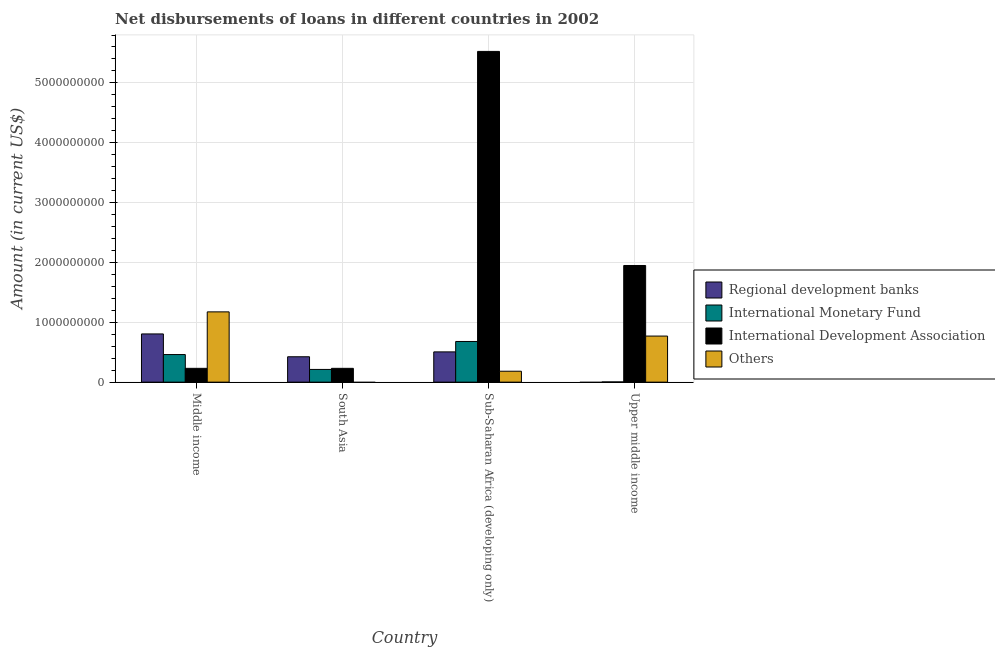How many different coloured bars are there?
Your answer should be very brief. 4. Are the number of bars per tick equal to the number of legend labels?
Give a very brief answer. No. What is the label of the 1st group of bars from the left?
Offer a very short reply. Middle income. What is the amount of loan disimbursed by international monetary fund in South Asia?
Ensure brevity in your answer.  2.13e+08. Across all countries, what is the maximum amount of loan disimbursed by regional development banks?
Provide a succinct answer. 8.05e+08. In which country was the amount of loan disimbursed by international development association maximum?
Offer a terse response. Sub-Saharan Africa (developing only). What is the total amount of loan disimbursed by international monetary fund in the graph?
Keep it short and to the point. 1.36e+09. What is the difference between the amount of loan disimbursed by international development association in Middle income and that in Sub-Saharan Africa (developing only)?
Offer a terse response. -5.30e+09. What is the difference between the amount of loan disimbursed by regional development banks in Middle income and the amount of loan disimbursed by international development association in South Asia?
Your answer should be very brief. 5.75e+08. What is the average amount of loan disimbursed by regional development banks per country?
Ensure brevity in your answer.  4.34e+08. What is the difference between the amount of loan disimbursed by regional development banks and amount of loan disimbursed by international monetary fund in Sub-Saharan Africa (developing only)?
Your answer should be very brief. -1.74e+08. In how many countries, is the amount of loan disimbursed by other organisations greater than 800000000 US$?
Provide a succinct answer. 1. What is the ratio of the amount of loan disimbursed by international development association in Sub-Saharan Africa (developing only) to that in Upper middle income?
Keep it short and to the point. 2.84. Is the difference between the amount of loan disimbursed by international development association in Middle income and South Asia greater than the difference between the amount of loan disimbursed by international monetary fund in Middle income and South Asia?
Offer a very short reply. No. What is the difference between the highest and the second highest amount of loan disimbursed by regional development banks?
Your answer should be compact. 3.00e+08. What is the difference between the highest and the lowest amount of loan disimbursed by international development association?
Offer a very short reply. 5.30e+09. In how many countries, is the amount of loan disimbursed by regional development banks greater than the average amount of loan disimbursed by regional development banks taken over all countries?
Keep it short and to the point. 2. Is the sum of the amount of loan disimbursed by international development association in South Asia and Upper middle income greater than the maximum amount of loan disimbursed by international monetary fund across all countries?
Provide a short and direct response. Yes. Is it the case that in every country, the sum of the amount of loan disimbursed by regional development banks and amount of loan disimbursed by international monetary fund is greater than the amount of loan disimbursed by international development association?
Provide a succinct answer. No. How many bars are there?
Offer a very short reply. 14. Are the values on the major ticks of Y-axis written in scientific E-notation?
Provide a short and direct response. No. Does the graph contain any zero values?
Make the answer very short. Yes. Does the graph contain grids?
Give a very brief answer. Yes. How are the legend labels stacked?
Offer a terse response. Vertical. What is the title of the graph?
Your answer should be compact. Net disbursements of loans in different countries in 2002. What is the label or title of the Y-axis?
Your answer should be very brief. Amount (in current US$). What is the Amount (in current US$) of Regional development banks in Middle income?
Ensure brevity in your answer.  8.05e+08. What is the Amount (in current US$) of International Monetary Fund in Middle income?
Offer a very short reply. 4.61e+08. What is the Amount (in current US$) in International Development Association in Middle income?
Your answer should be very brief. 2.31e+08. What is the Amount (in current US$) of Others in Middle income?
Your response must be concise. 1.17e+09. What is the Amount (in current US$) in Regional development banks in South Asia?
Provide a short and direct response. 4.24e+08. What is the Amount (in current US$) in International Monetary Fund in South Asia?
Make the answer very short. 2.13e+08. What is the Amount (in current US$) in International Development Association in South Asia?
Give a very brief answer. 2.31e+08. What is the Amount (in current US$) of Regional development banks in Sub-Saharan Africa (developing only)?
Your answer should be compact. 5.06e+08. What is the Amount (in current US$) of International Monetary Fund in Sub-Saharan Africa (developing only)?
Your answer should be compact. 6.80e+08. What is the Amount (in current US$) in International Development Association in Sub-Saharan Africa (developing only)?
Your answer should be compact. 5.53e+09. What is the Amount (in current US$) in Others in Sub-Saharan Africa (developing only)?
Make the answer very short. 1.82e+08. What is the Amount (in current US$) of International Monetary Fund in Upper middle income?
Make the answer very short. 3.73e+06. What is the Amount (in current US$) of International Development Association in Upper middle income?
Make the answer very short. 1.95e+09. What is the Amount (in current US$) in Others in Upper middle income?
Keep it short and to the point. 7.70e+08. Across all countries, what is the maximum Amount (in current US$) in Regional development banks?
Offer a very short reply. 8.05e+08. Across all countries, what is the maximum Amount (in current US$) of International Monetary Fund?
Keep it short and to the point. 6.80e+08. Across all countries, what is the maximum Amount (in current US$) of International Development Association?
Offer a terse response. 5.53e+09. Across all countries, what is the maximum Amount (in current US$) of Others?
Your answer should be very brief. 1.17e+09. Across all countries, what is the minimum Amount (in current US$) of Regional development banks?
Your answer should be very brief. 0. Across all countries, what is the minimum Amount (in current US$) in International Monetary Fund?
Provide a succinct answer. 3.73e+06. Across all countries, what is the minimum Amount (in current US$) in International Development Association?
Provide a succinct answer. 2.31e+08. Across all countries, what is the minimum Amount (in current US$) in Others?
Your answer should be compact. 0. What is the total Amount (in current US$) of Regional development banks in the graph?
Your answer should be very brief. 1.74e+09. What is the total Amount (in current US$) in International Monetary Fund in the graph?
Keep it short and to the point. 1.36e+09. What is the total Amount (in current US$) of International Development Association in the graph?
Offer a terse response. 7.94e+09. What is the total Amount (in current US$) in Others in the graph?
Your answer should be very brief. 2.13e+09. What is the difference between the Amount (in current US$) in Regional development banks in Middle income and that in South Asia?
Your answer should be very brief. 3.81e+08. What is the difference between the Amount (in current US$) of International Monetary Fund in Middle income and that in South Asia?
Your answer should be compact. 2.48e+08. What is the difference between the Amount (in current US$) in International Development Association in Middle income and that in South Asia?
Your answer should be compact. -3.60e+04. What is the difference between the Amount (in current US$) in Regional development banks in Middle income and that in Sub-Saharan Africa (developing only)?
Your answer should be compact. 3.00e+08. What is the difference between the Amount (in current US$) of International Monetary Fund in Middle income and that in Sub-Saharan Africa (developing only)?
Give a very brief answer. -2.19e+08. What is the difference between the Amount (in current US$) of International Development Association in Middle income and that in Sub-Saharan Africa (developing only)?
Provide a short and direct response. -5.30e+09. What is the difference between the Amount (in current US$) in Others in Middle income and that in Sub-Saharan Africa (developing only)?
Offer a terse response. 9.92e+08. What is the difference between the Amount (in current US$) of International Monetary Fund in Middle income and that in Upper middle income?
Offer a very short reply. 4.57e+08. What is the difference between the Amount (in current US$) of International Development Association in Middle income and that in Upper middle income?
Ensure brevity in your answer.  -1.72e+09. What is the difference between the Amount (in current US$) of Others in Middle income and that in Upper middle income?
Keep it short and to the point. 4.04e+08. What is the difference between the Amount (in current US$) in Regional development banks in South Asia and that in Sub-Saharan Africa (developing only)?
Give a very brief answer. -8.13e+07. What is the difference between the Amount (in current US$) of International Monetary Fund in South Asia and that in Sub-Saharan Africa (developing only)?
Provide a short and direct response. -4.67e+08. What is the difference between the Amount (in current US$) of International Development Association in South Asia and that in Sub-Saharan Africa (developing only)?
Offer a very short reply. -5.30e+09. What is the difference between the Amount (in current US$) in International Monetary Fund in South Asia and that in Upper middle income?
Give a very brief answer. 2.09e+08. What is the difference between the Amount (in current US$) in International Development Association in South Asia and that in Upper middle income?
Make the answer very short. -1.72e+09. What is the difference between the Amount (in current US$) in International Monetary Fund in Sub-Saharan Africa (developing only) and that in Upper middle income?
Offer a very short reply. 6.76e+08. What is the difference between the Amount (in current US$) in International Development Association in Sub-Saharan Africa (developing only) and that in Upper middle income?
Give a very brief answer. 3.58e+09. What is the difference between the Amount (in current US$) of Others in Sub-Saharan Africa (developing only) and that in Upper middle income?
Ensure brevity in your answer.  -5.87e+08. What is the difference between the Amount (in current US$) of Regional development banks in Middle income and the Amount (in current US$) of International Monetary Fund in South Asia?
Offer a terse response. 5.93e+08. What is the difference between the Amount (in current US$) of Regional development banks in Middle income and the Amount (in current US$) of International Development Association in South Asia?
Your response must be concise. 5.75e+08. What is the difference between the Amount (in current US$) in International Monetary Fund in Middle income and the Amount (in current US$) in International Development Association in South Asia?
Your response must be concise. 2.30e+08. What is the difference between the Amount (in current US$) of Regional development banks in Middle income and the Amount (in current US$) of International Monetary Fund in Sub-Saharan Africa (developing only)?
Offer a very short reply. 1.26e+08. What is the difference between the Amount (in current US$) in Regional development banks in Middle income and the Amount (in current US$) in International Development Association in Sub-Saharan Africa (developing only)?
Provide a succinct answer. -4.72e+09. What is the difference between the Amount (in current US$) in Regional development banks in Middle income and the Amount (in current US$) in Others in Sub-Saharan Africa (developing only)?
Give a very brief answer. 6.23e+08. What is the difference between the Amount (in current US$) in International Monetary Fund in Middle income and the Amount (in current US$) in International Development Association in Sub-Saharan Africa (developing only)?
Offer a terse response. -5.06e+09. What is the difference between the Amount (in current US$) in International Monetary Fund in Middle income and the Amount (in current US$) in Others in Sub-Saharan Africa (developing only)?
Offer a very short reply. 2.79e+08. What is the difference between the Amount (in current US$) of International Development Association in Middle income and the Amount (in current US$) of Others in Sub-Saharan Africa (developing only)?
Keep it short and to the point. 4.83e+07. What is the difference between the Amount (in current US$) in Regional development banks in Middle income and the Amount (in current US$) in International Monetary Fund in Upper middle income?
Offer a terse response. 8.02e+08. What is the difference between the Amount (in current US$) of Regional development banks in Middle income and the Amount (in current US$) of International Development Association in Upper middle income?
Keep it short and to the point. -1.14e+09. What is the difference between the Amount (in current US$) in Regional development banks in Middle income and the Amount (in current US$) in Others in Upper middle income?
Your response must be concise. 3.57e+07. What is the difference between the Amount (in current US$) of International Monetary Fund in Middle income and the Amount (in current US$) of International Development Association in Upper middle income?
Your answer should be compact. -1.49e+09. What is the difference between the Amount (in current US$) of International Monetary Fund in Middle income and the Amount (in current US$) of Others in Upper middle income?
Offer a very short reply. -3.09e+08. What is the difference between the Amount (in current US$) in International Development Association in Middle income and the Amount (in current US$) in Others in Upper middle income?
Your answer should be very brief. -5.39e+08. What is the difference between the Amount (in current US$) in Regional development banks in South Asia and the Amount (in current US$) in International Monetary Fund in Sub-Saharan Africa (developing only)?
Make the answer very short. -2.55e+08. What is the difference between the Amount (in current US$) in Regional development banks in South Asia and the Amount (in current US$) in International Development Association in Sub-Saharan Africa (developing only)?
Your answer should be very brief. -5.10e+09. What is the difference between the Amount (in current US$) in Regional development banks in South Asia and the Amount (in current US$) in Others in Sub-Saharan Africa (developing only)?
Your answer should be compact. 2.42e+08. What is the difference between the Amount (in current US$) in International Monetary Fund in South Asia and the Amount (in current US$) in International Development Association in Sub-Saharan Africa (developing only)?
Keep it short and to the point. -5.31e+09. What is the difference between the Amount (in current US$) in International Monetary Fund in South Asia and the Amount (in current US$) in Others in Sub-Saharan Africa (developing only)?
Offer a very short reply. 3.01e+07. What is the difference between the Amount (in current US$) in International Development Association in South Asia and the Amount (in current US$) in Others in Sub-Saharan Africa (developing only)?
Your answer should be very brief. 4.84e+07. What is the difference between the Amount (in current US$) in Regional development banks in South Asia and the Amount (in current US$) in International Monetary Fund in Upper middle income?
Provide a short and direct response. 4.21e+08. What is the difference between the Amount (in current US$) in Regional development banks in South Asia and the Amount (in current US$) in International Development Association in Upper middle income?
Offer a very short reply. -1.52e+09. What is the difference between the Amount (in current US$) of Regional development banks in South Asia and the Amount (in current US$) of Others in Upper middle income?
Your answer should be compact. -3.46e+08. What is the difference between the Amount (in current US$) in International Monetary Fund in South Asia and the Amount (in current US$) in International Development Association in Upper middle income?
Make the answer very short. -1.74e+09. What is the difference between the Amount (in current US$) in International Monetary Fund in South Asia and the Amount (in current US$) in Others in Upper middle income?
Offer a very short reply. -5.57e+08. What is the difference between the Amount (in current US$) in International Development Association in South Asia and the Amount (in current US$) in Others in Upper middle income?
Provide a succinct answer. -5.39e+08. What is the difference between the Amount (in current US$) in Regional development banks in Sub-Saharan Africa (developing only) and the Amount (in current US$) in International Monetary Fund in Upper middle income?
Provide a succinct answer. 5.02e+08. What is the difference between the Amount (in current US$) of Regional development banks in Sub-Saharan Africa (developing only) and the Amount (in current US$) of International Development Association in Upper middle income?
Your answer should be compact. -1.44e+09. What is the difference between the Amount (in current US$) in Regional development banks in Sub-Saharan Africa (developing only) and the Amount (in current US$) in Others in Upper middle income?
Ensure brevity in your answer.  -2.64e+08. What is the difference between the Amount (in current US$) in International Monetary Fund in Sub-Saharan Africa (developing only) and the Amount (in current US$) in International Development Association in Upper middle income?
Your response must be concise. -1.27e+09. What is the difference between the Amount (in current US$) in International Monetary Fund in Sub-Saharan Africa (developing only) and the Amount (in current US$) in Others in Upper middle income?
Offer a very short reply. -9.02e+07. What is the difference between the Amount (in current US$) in International Development Association in Sub-Saharan Africa (developing only) and the Amount (in current US$) in Others in Upper middle income?
Keep it short and to the point. 4.76e+09. What is the average Amount (in current US$) of Regional development banks per country?
Provide a succinct answer. 4.34e+08. What is the average Amount (in current US$) of International Monetary Fund per country?
Provide a short and direct response. 3.39e+08. What is the average Amount (in current US$) in International Development Association per country?
Ensure brevity in your answer.  1.98e+09. What is the average Amount (in current US$) of Others per country?
Your answer should be very brief. 5.32e+08. What is the difference between the Amount (in current US$) of Regional development banks and Amount (in current US$) of International Monetary Fund in Middle income?
Make the answer very short. 3.44e+08. What is the difference between the Amount (in current US$) of Regional development banks and Amount (in current US$) of International Development Association in Middle income?
Provide a succinct answer. 5.75e+08. What is the difference between the Amount (in current US$) of Regional development banks and Amount (in current US$) of Others in Middle income?
Provide a short and direct response. -3.69e+08. What is the difference between the Amount (in current US$) of International Monetary Fund and Amount (in current US$) of International Development Association in Middle income?
Your answer should be very brief. 2.30e+08. What is the difference between the Amount (in current US$) of International Monetary Fund and Amount (in current US$) of Others in Middle income?
Provide a succinct answer. -7.13e+08. What is the difference between the Amount (in current US$) of International Development Association and Amount (in current US$) of Others in Middle income?
Offer a terse response. -9.43e+08. What is the difference between the Amount (in current US$) in Regional development banks and Amount (in current US$) in International Monetary Fund in South Asia?
Offer a very short reply. 2.12e+08. What is the difference between the Amount (in current US$) in Regional development banks and Amount (in current US$) in International Development Association in South Asia?
Your answer should be very brief. 1.93e+08. What is the difference between the Amount (in current US$) of International Monetary Fund and Amount (in current US$) of International Development Association in South Asia?
Keep it short and to the point. -1.82e+07. What is the difference between the Amount (in current US$) in Regional development banks and Amount (in current US$) in International Monetary Fund in Sub-Saharan Africa (developing only)?
Provide a short and direct response. -1.74e+08. What is the difference between the Amount (in current US$) in Regional development banks and Amount (in current US$) in International Development Association in Sub-Saharan Africa (developing only)?
Offer a very short reply. -5.02e+09. What is the difference between the Amount (in current US$) in Regional development banks and Amount (in current US$) in Others in Sub-Saharan Africa (developing only)?
Make the answer very short. 3.23e+08. What is the difference between the Amount (in current US$) in International Monetary Fund and Amount (in current US$) in International Development Association in Sub-Saharan Africa (developing only)?
Keep it short and to the point. -4.85e+09. What is the difference between the Amount (in current US$) of International Monetary Fund and Amount (in current US$) of Others in Sub-Saharan Africa (developing only)?
Make the answer very short. 4.97e+08. What is the difference between the Amount (in current US$) in International Development Association and Amount (in current US$) in Others in Sub-Saharan Africa (developing only)?
Provide a succinct answer. 5.34e+09. What is the difference between the Amount (in current US$) in International Monetary Fund and Amount (in current US$) in International Development Association in Upper middle income?
Your answer should be very brief. -1.95e+09. What is the difference between the Amount (in current US$) in International Monetary Fund and Amount (in current US$) in Others in Upper middle income?
Give a very brief answer. -7.66e+08. What is the difference between the Amount (in current US$) of International Development Association and Amount (in current US$) of Others in Upper middle income?
Provide a short and direct response. 1.18e+09. What is the ratio of the Amount (in current US$) in Regional development banks in Middle income to that in South Asia?
Offer a terse response. 1.9. What is the ratio of the Amount (in current US$) in International Monetary Fund in Middle income to that in South Asia?
Your answer should be very brief. 2.17. What is the ratio of the Amount (in current US$) of Regional development banks in Middle income to that in Sub-Saharan Africa (developing only)?
Give a very brief answer. 1.59. What is the ratio of the Amount (in current US$) in International Monetary Fund in Middle income to that in Sub-Saharan Africa (developing only)?
Your response must be concise. 0.68. What is the ratio of the Amount (in current US$) of International Development Association in Middle income to that in Sub-Saharan Africa (developing only)?
Ensure brevity in your answer.  0.04. What is the ratio of the Amount (in current US$) in Others in Middle income to that in Sub-Saharan Africa (developing only)?
Keep it short and to the point. 6.43. What is the ratio of the Amount (in current US$) of International Monetary Fund in Middle income to that in Upper middle income?
Your answer should be very brief. 123.6. What is the ratio of the Amount (in current US$) in International Development Association in Middle income to that in Upper middle income?
Provide a succinct answer. 0.12. What is the ratio of the Amount (in current US$) of Others in Middle income to that in Upper middle income?
Keep it short and to the point. 1.53. What is the ratio of the Amount (in current US$) of Regional development banks in South Asia to that in Sub-Saharan Africa (developing only)?
Provide a succinct answer. 0.84. What is the ratio of the Amount (in current US$) in International Monetary Fund in South Asia to that in Sub-Saharan Africa (developing only)?
Provide a succinct answer. 0.31. What is the ratio of the Amount (in current US$) in International Development Association in South Asia to that in Sub-Saharan Africa (developing only)?
Make the answer very short. 0.04. What is the ratio of the Amount (in current US$) in International Monetary Fund in South Asia to that in Upper middle income?
Offer a very short reply. 56.99. What is the ratio of the Amount (in current US$) of International Development Association in South Asia to that in Upper middle income?
Your answer should be very brief. 0.12. What is the ratio of the Amount (in current US$) in International Monetary Fund in Sub-Saharan Africa (developing only) to that in Upper middle income?
Provide a short and direct response. 182.19. What is the ratio of the Amount (in current US$) in International Development Association in Sub-Saharan Africa (developing only) to that in Upper middle income?
Your answer should be compact. 2.84. What is the ratio of the Amount (in current US$) in Others in Sub-Saharan Africa (developing only) to that in Upper middle income?
Provide a short and direct response. 0.24. What is the difference between the highest and the second highest Amount (in current US$) in Regional development banks?
Your response must be concise. 3.00e+08. What is the difference between the highest and the second highest Amount (in current US$) of International Monetary Fund?
Offer a terse response. 2.19e+08. What is the difference between the highest and the second highest Amount (in current US$) in International Development Association?
Your response must be concise. 3.58e+09. What is the difference between the highest and the second highest Amount (in current US$) of Others?
Your answer should be compact. 4.04e+08. What is the difference between the highest and the lowest Amount (in current US$) of Regional development banks?
Make the answer very short. 8.05e+08. What is the difference between the highest and the lowest Amount (in current US$) of International Monetary Fund?
Your answer should be compact. 6.76e+08. What is the difference between the highest and the lowest Amount (in current US$) of International Development Association?
Offer a very short reply. 5.30e+09. What is the difference between the highest and the lowest Amount (in current US$) in Others?
Provide a succinct answer. 1.17e+09. 